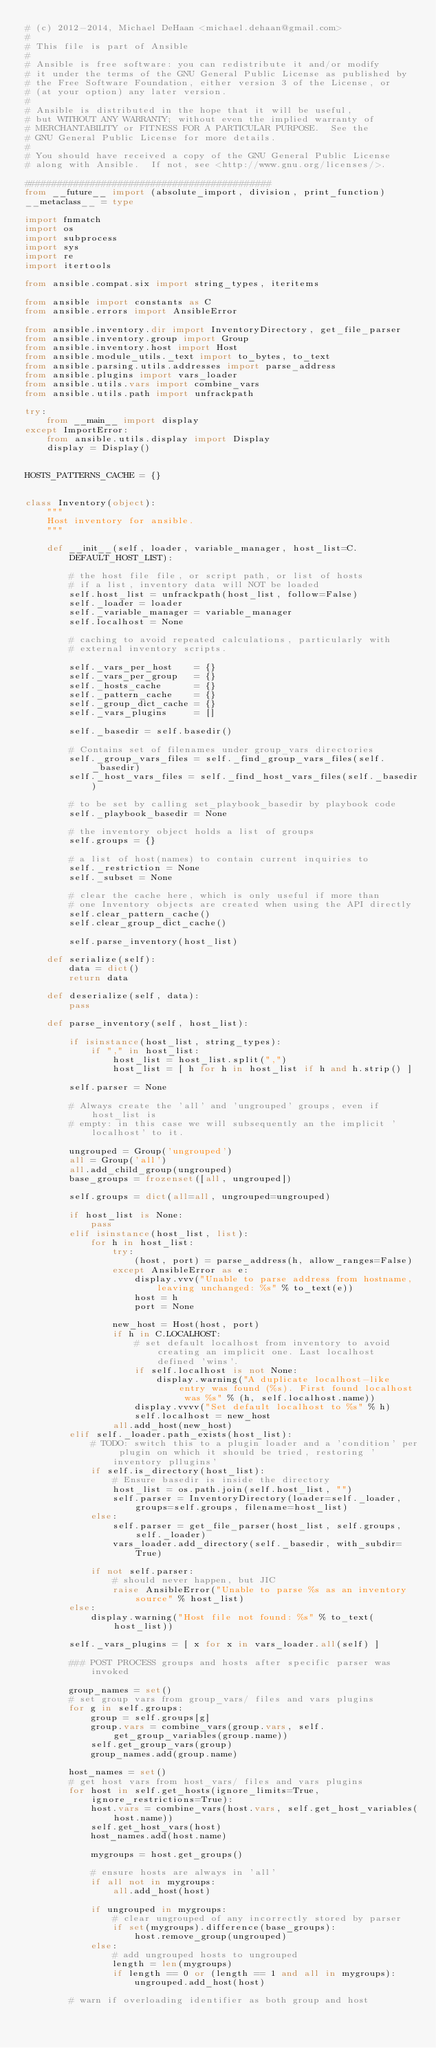Convert code to text. <code><loc_0><loc_0><loc_500><loc_500><_Python_># (c) 2012-2014, Michael DeHaan <michael.dehaan@gmail.com>
#
# This file is part of Ansible
#
# Ansible is free software: you can redistribute it and/or modify
# it under the terms of the GNU General Public License as published by
# the Free Software Foundation, either version 3 of the License, or
# (at your option) any later version.
#
# Ansible is distributed in the hope that it will be useful,
# but WITHOUT ANY WARRANTY; without even the implied warranty of
# MERCHANTABILITY or FITNESS FOR A PARTICULAR PURPOSE.  See the
# GNU General Public License for more details.
#
# You should have received a copy of the GNU General Public License
# along with Ansible.  If not, see <http://www.gnu.org/licenses/>.

#############################################
from __future__ import (absolute_import, division, print_function)
__metaclass__ = type

import fnmatch
import os
import subprocess
import sys
import re
import itertools

from ansible.compat.six import string_types, iteritems

from ansible import constants as C
from ansible.errors import AnsibleError

from ansible.inventory.dir import InventoryDirectory, get_file_parser
from ansible.inventory.group import Group
from ansible.inventory.host import Host
from ansible.module_utils._text import to_bytes, to_text
from ansible.parsing.utils.addresses import parse_address
from ansible.plugins import vars_loader
from ansible.utils.vars import combine_vars
from ansible.utils.path import unfrackpath

try:
    from __main__ import display
except ImportError:
    from ansible.utils.display import Display
    display = Display()


HOSTS_PATTERNS_CACHE = {}


class Inventory(object):
    """
    Host inventory for ansible.
    """

    def __init__(self, loader, variable_manager, host_list=C.DEFAULT_HOST_LIST):

        # the host file file, or script path, or list of hosts
        # if a list, inventory data will NOT be loaded
        self.host_list = unfrackpath(host_list, follow=False)
        self._loader = loader
        self._variable_manager = variable_manager
        self.localhost = None

        # caching to avoid repeated calculations, particularly with
        # external inventory scripts.

        self._vars_per_host    = {}
        self._vars_per_group   = {}
        self._hosts_cache      = {}
        self._pattern_cache    = {}
        self._group_dict_cache = {}
        self._vars_plugins     = []

        self._basedir = self.basedir()

        # Contains set of filenames under group_vars directories
        self._group_vars_files = self._find_group_vars_files(self._basedir)
        self._host_vars_files = self._find_host_vars_files(self._basedir)

        # to be set by calling set_playbook_basedir by playbook code
        self._playbook_basedir = None

        # the inventory object holds a list of groups
        self.groups = {}

        # a list of host(names) to contain current inquiries to
        self._restriction = None
        self._subset = None

        # clear the cache here, which is only useful if more than
        # one Inventory objects are created when using the API directly
        self.clear_pattern_cache()
        self.clear_group_dict_cache()

        self.parse_inventory(host_list)

    def serialize(self):
        data = dict()
        return data

    def deserialize(self, data):
        pass

    def parse_inventory(self, host_list):

        if isinstance(host_list, string_types):
            if "," in host_list:
                host_list = host_list.split(",")
                host_list = [ h for h in host_list if h and h.strip() ]

        self.parser = None

        # Always create the 'all' and 'ungrouped' groups, even if host_list is
        # empty: in this case we will subsequently an the implicit 'localhost' to it.

        ungrouped = Group('ungrouped')
        all = Group('all')
        all.add_child_group(ungrouped)
        base_groups = frozenset([all, ungrouped])

        self.groups = dict(all=all, ungrouped=ungrouped)

        if host_list is None:
            pass
        elif isinstance(host_list, list):
            for h in host_list:
                try:
                    (host, port) = parse_address(h, allow_ranges=False)
                except AnsibleError as e:
                    display.vvv("Unable to parse address from hostname, leaving unchanged: %s" % to_text(e))
                    host = h
                    port = None

                new_host = Host(host, port)
                if h in C.LOCALHOST:
                    # set default localhost from inventory to avoid creating an implicit one. Last localhost defined 'wins'.
                    if self.localhost is not None:
                        display.warning("A duplicate localhost-like entry was found (%s). First found localhost was %s" % (h, self.localhost.name))
                    display.vvvv("Set default localhost to %s" % h)
                    self.localhost = new_host
                all.add_host(new_host)
        elif self._loader.path_exists(host_list):
            # TODO: switch this to a plugin loader and a 'condition' per plugin on which it should be tried, restoring 'inventory pllugins'
            if self.is_directory(host_list):
                # Ensure basedir is inside the directory
                host_list = os.path.join(self.host_list, "")
                self.parser = InventoryDirectory(loader=self._loader, groups=self.groups, filename=host_list)
            else:
                self.parser = get_file_parser(host_list, self.groups, self._loader)
                vars_loader.add_directory(self._basedir, with_subdir=True)

            if not self.parser:
                # should never happen, but JIC
                raise AnsibleError("Unable to parse %s as an inventory source" % host_list)
        else:
            display.warning("Host file not found: %s" % to_text(host_list))

        self._vars_plugins = [ x for x in vars_loader.all(self) ]

        ### POST PROCESS groups and hosts after specific parser was invoked

        group_names = set()
        # set group vars from group_vars/ files and vars plugins
        for g in self.groups:
            group = self.groups[g]
            group.vars = combine_vars(group.vars, self.get_group_variables(group.name))
            self.get_group_vars(group)
            group_names.add(group.name)

        host_names = set()
        # get host vars from host_vars/ files and vars plugins
        for host in self.get_hosts(ignore_limits=True, ignore_restrictions=True):
            host.vars = combine_vars(host.vars, self.get_host_variables(host.name))
            self.get_host_vars(host)
            host_names.add(host.name)

            mygroups = host.get_groups()

            # ensure hosts are always in 'all'
            if all not in mygroups:
                all.add_host(host)

            if ungrouped in mygroups:
                # clear ungrouped of any incorrectly stored by parser
                if set(mygroups).difference(base_groups):
                    host.remove_group(ungrouped)
            else:
                # add ungrouped hosts to ungrouped
                length = len(mygroups)
                if length == 0 or (length == 1 and all in mygroups):
                    ungrouped.add_host(host)

        # warn if overloading identifier as both group and host</code> 